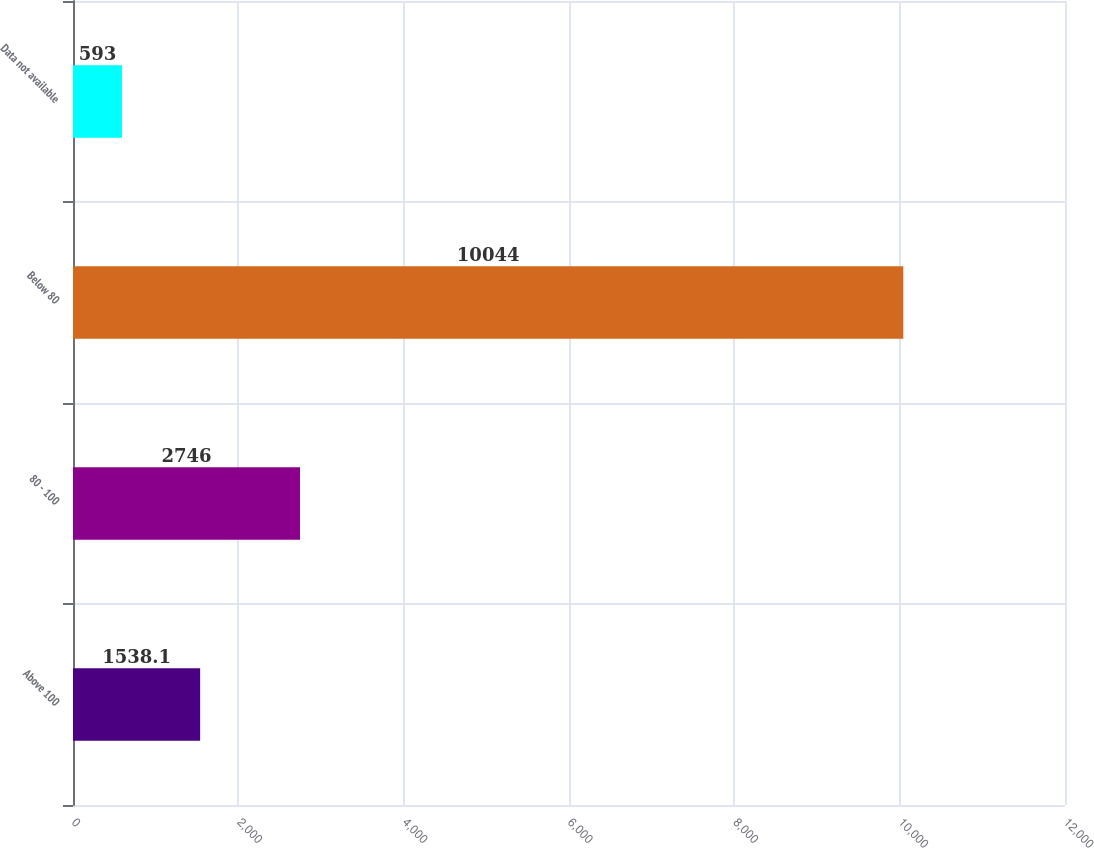<chart> <loc_0><loc_0><loc_500><loc_500><bar_chart><fcel>Above 100<fcel>80 - 100<fcel>Below 80<fcel>Data not available<nl><fcel>1538.1<fcel>2746<fcel>10044<fcel>593<nl></chart> 